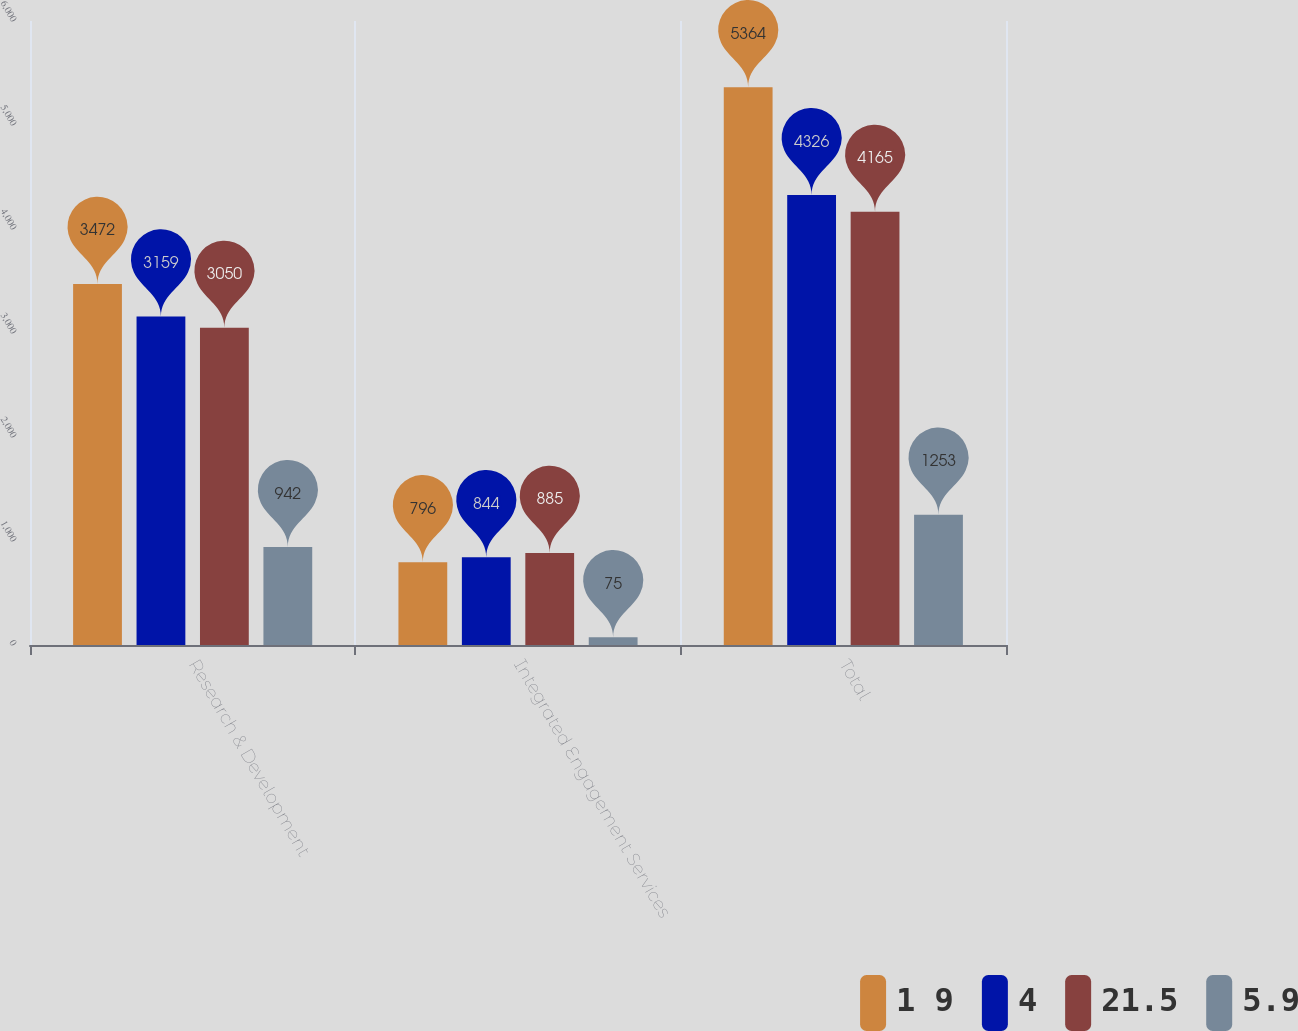Convert chart. <chart><loc_0><loc_0><loc_500><loc_500><stacked_bar_chart><ecel><fcel>Research & Development<fcel>Integrated Engagement Services<fcel>Total<nl><fcel>1 9<fcel>3472<fcel>796<fcel>5364<nl><fcel>4<fcel>3159<fcel>844<fcel>4326<nl><fcel>21.5<fcel>3050<fcel>885<fcel>4165<nl><fcel>5.9<fcel>942<fcel>75<fcel>1253<nl></chart> 